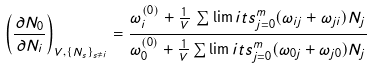Convert formula to latex. <formula><loc_0><loc_0><loc_500><loc_500>\left ( \frac { \partial N _ { 0 } } { \partial N _ { i } } \right ) _ { V , \{ N _ { s } \} _ { s \neq i } } = \frac { \omega _ { i } ^ { ( 0 ) } + \frac { 1 } { V } \, \sum \lim i t s _ { j = 0 } ^ { m } ( \omega _ { i j } + \omega _ { j i } ) N _ { j } } { \omega _ { 0 } ^ { ( 0 ) } + \frac { 1 } { V } \sum \lim i t s _ { j = 0 } ^ { m } ( \omega _ { 0 j } + \omega _ { j 0 } ) N _ { j } }</formula> 